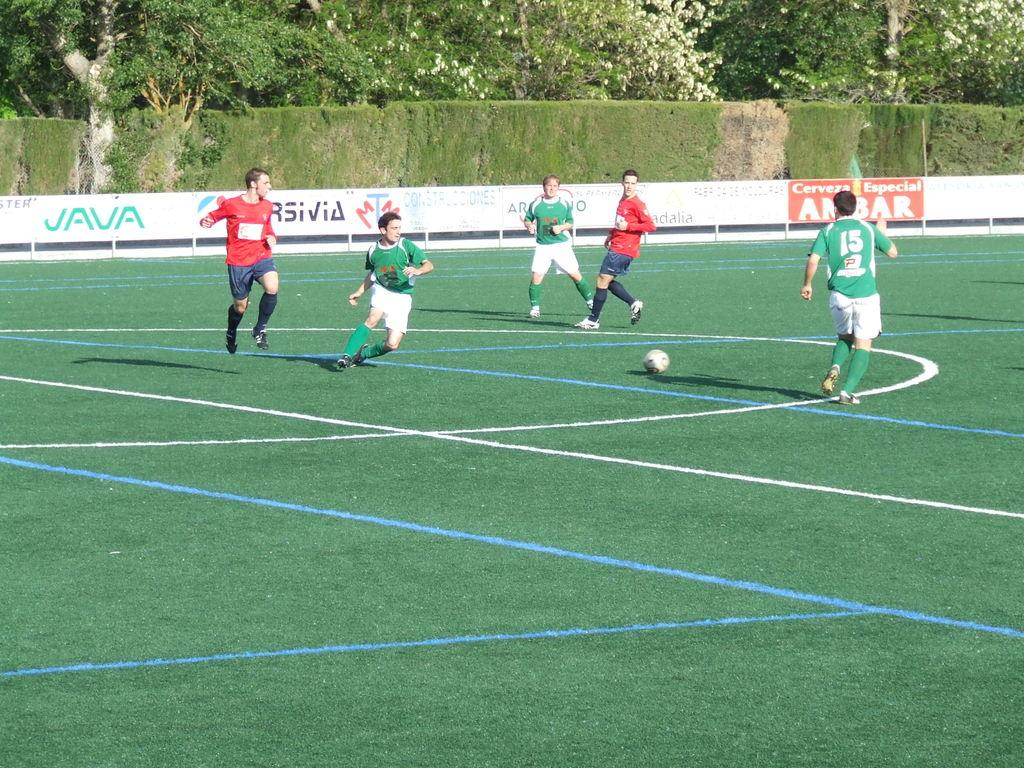Provide a one-sentence caption for the provided image. A group of people playing soccer with a JAVA advertisement behind them. 